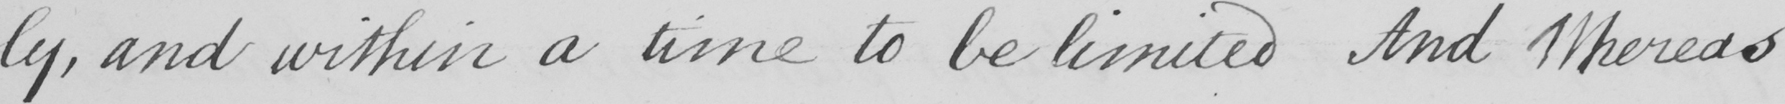Please provide the text content of this handwritten line. -ly, and within a time to be limited And Whereas 